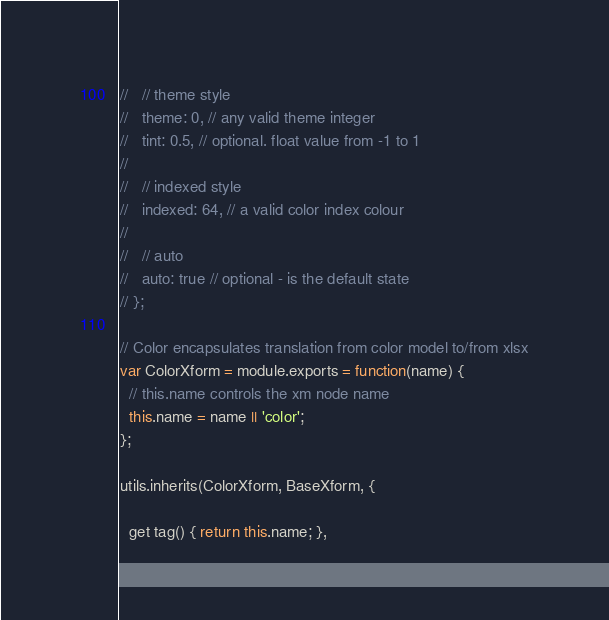Convert code to text. <code><loc_0><loc_0><loc_500><loc_500><_JavaScript_>//   // theme style
//   theme: 0, // any valid theme integer
//   tint: 0.5, // optional. float value from -1 to 1
//
//   // indexed style
//   indexed: 64, // a valid color index colour
//
//   // auto
//   auto: true // optional - is the default state
// };

// Color encapsulates translation from color model to/from xlsx
var ColorXform = module.exports = function(name) {
  // this.name controls the xm node name
  this.name = name || 'color';
};

utils.inherits(ColorXform, BaseXform, {

  get tag() { return this.name; },
</code> 